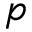<formula> <loc_0><loc_0><loc_500><loc_500>p</formula> 